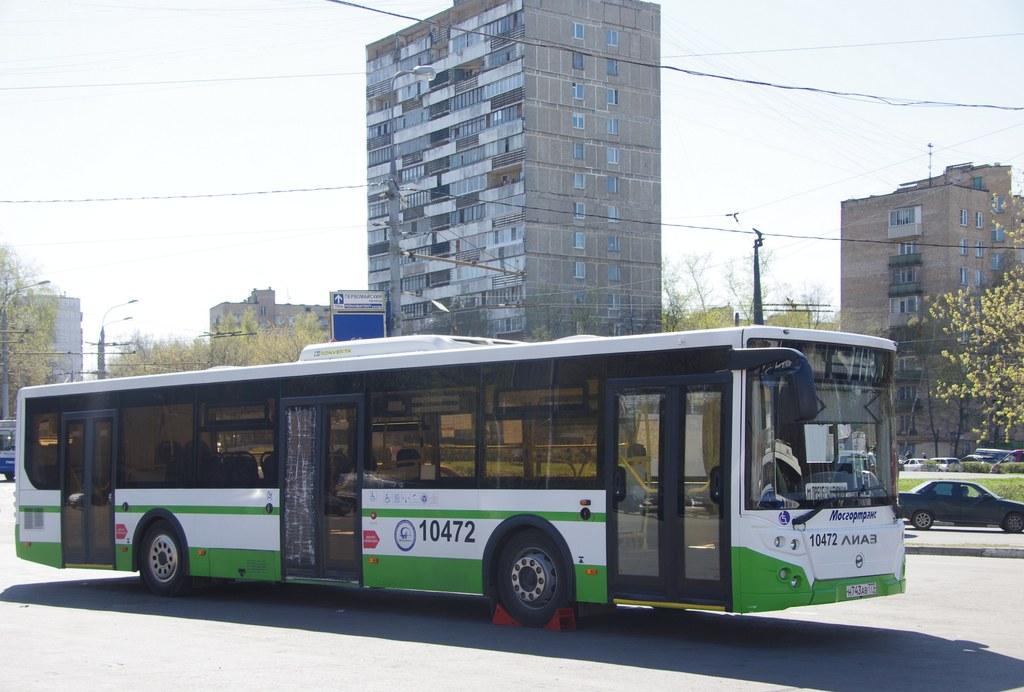What is the bus number?
Keep it short and to the point. 10472. 